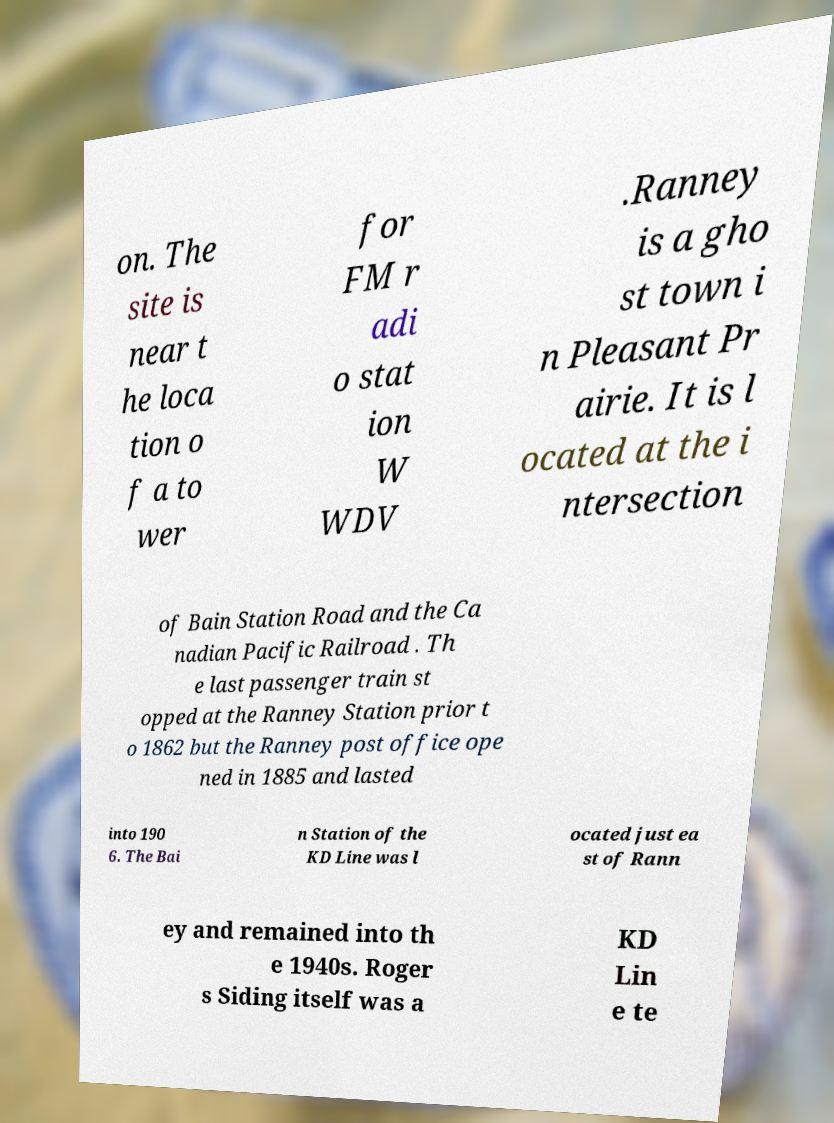Please identify and transcribe the text found in this image. on. The site is near t he loca tion o f a to wer for FM r adi o stat ion W WDV .Ranney is a gho st town i n Pleasant Pr airie. It is l ocated at the i ntersection of Bain Station Road and the Ca nadian Pacific Railroad . Th e last passenger train st opped at the Ranney Station prior t o 1862 but the Ranney post office ope ned in 1885 and lasted into 190 6. The Bai n Station of the KD Line was l ocated just ea st of Rann ey and remained into th e 1940s. Roger s Siding itself was a KD Lin e te 